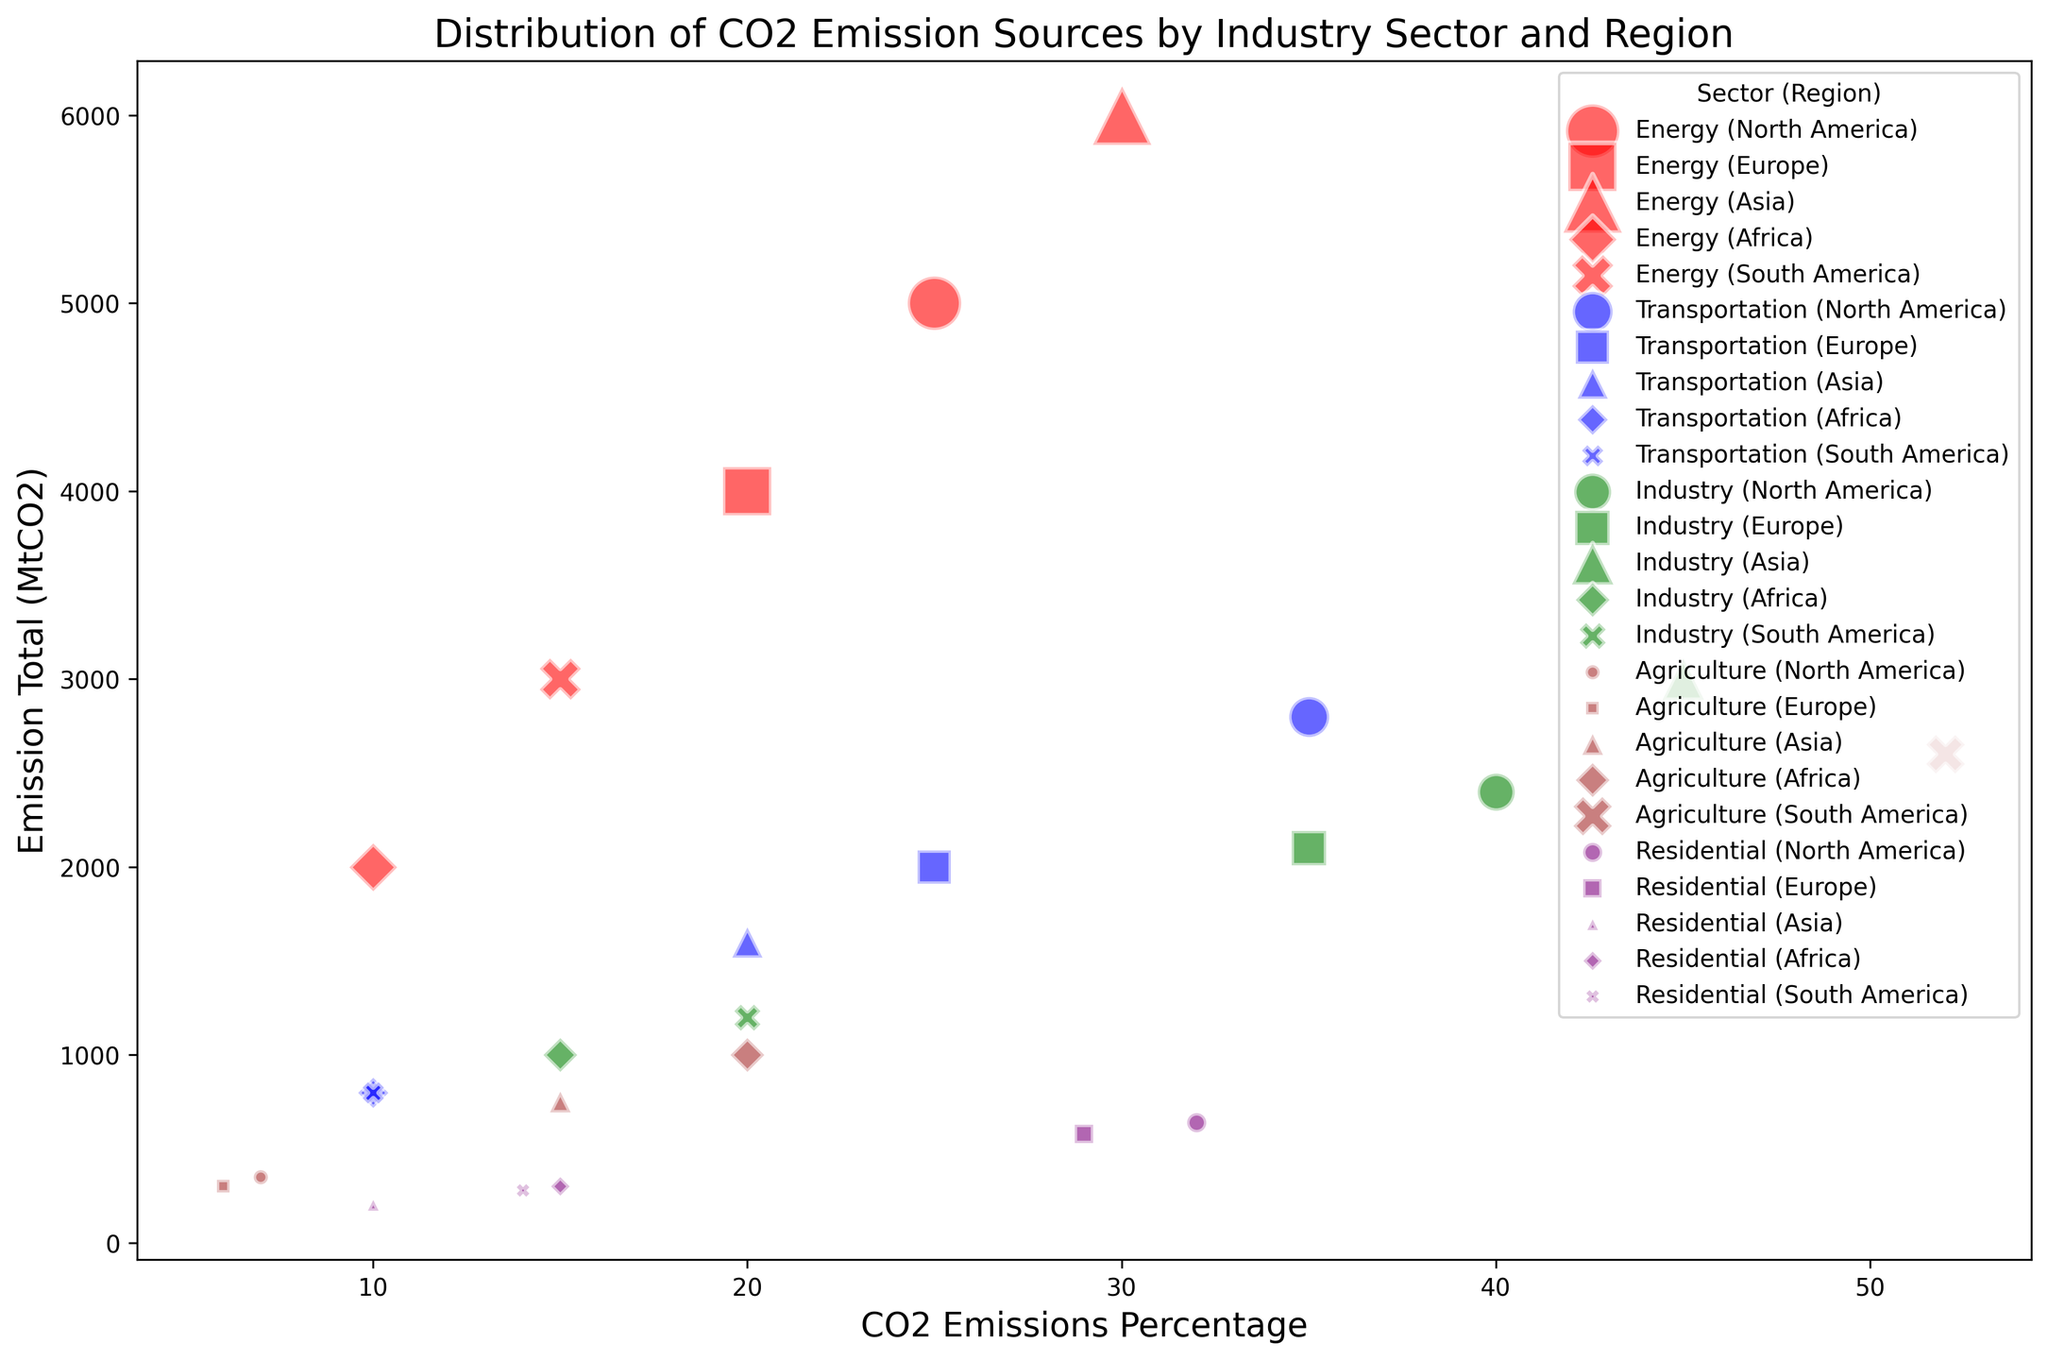What is the highest total CO2 emission value in the Energy sector? Look for the largest circle (indicating the largest emission total) within the red bubbles, representing the Energy sector. The largest value is 6000 MtCO2 in Asia.
Answer: 6000 MtCO2 Which region has the highest percentage of CO2 emissions in the Agriculture sector? Identify the brown bubbles, which represent the Agriculture sector, and find the one with the highest value on the x-axis (CO2 Emissions Percentage). South America has the highest, with 52%.
Answer: South America How does the total CO2 emission from the Industry sector in Asia compare to Europe? Identify the green bubbles representing the Industry sector for both Asia and Europe. Asia has a total emission of 3000 MtCO2, while Europe has 2100 MtCO2.
Answer: Asia > Europe Which sector has the smallest total CO2 emission in South America? Find the bubbles indicating South America (X marker) and compare the size of the circles. The smallest is the purple bubble for the Residential sector with 280 MtCO2.
Answer: Residential What is the sum of CO2 emissions from the Transportation sector in North America and Europe? Find the blue bubbles for North America and Europe. The total emissions are 2800 (North America) + 2000 (Europe) = 4800 MtCO2.
Answer: 4800 MtCO2 Which sector and region combination has the most significant percentage of CO2 emissions? Look for the bubble furthest to the right on the x-axis, which represents CO2 Emissions Percentage. It is the Agriculture sector in South America with 52%.
Answer: Agriculture in South America How does the emission total from Agriculture in Africa compare to Transportation in Africa? Identify the brown bubble for Agriculture in Africa with an emission total of 1000 MtCO2 and the blue bubble for Transportation in Africa with 800 MtCO2.
Answer: Agriculture > Transportation What is the smallest percentage of CO2 emissions in the Transportation sector, and which region does it correspond to? Locate the blue bubbles for the Transportation sector and identify the smallest value on the x-axis. The smallest is 10% in both Africa and South America.
Answer: 10%, Africa and South America Which region has the highest CO2 emissions in the Residential sector? Identify the purple bubbles for the Residential sector and look for the largest circle. This is in North America with 640 MtCO2.
Answer: North America 